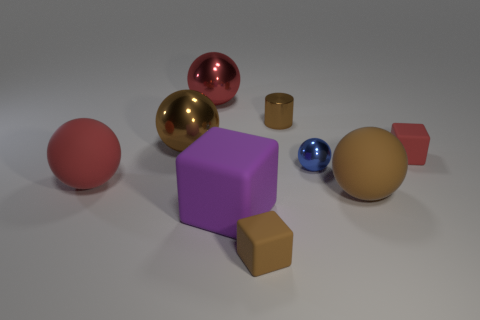Are there more brown cylinders than big yellow matte cylinders?
Offer a very short reply. Yes. What shape is the big brown thing that is on the right side of the brown block in front of the blue metal thing?
Your answer should be very brief. Sphere. Are there more blue objects behind the big red rubber object than large blue shiny objects?
Give a very brief answer. Yes. What number of rubber things are behind the red rubber sphere in front of the tiny shiny cylinder?
Give a very brief answer. 1. Is the material of the small object that is left of the tiny brown metallic thing the same as the red ball in front of the small metal cylinder?
Offer a very short reply. Yes. What number of tiny things have the same shape as the large purple matte thing?
Offer a very short reply. 2. Does the brown cube have the same material as the small brown object to the right of the brown cube?
Your answer should be very brief. No. There is a brown cylinder that is the same size as the red block; what material is it?
Offer a very short reply. Metal. Is there a brown block that has the same size as the blue shiny ball?
Make the answer very short. Yes. What shape is the blue metallic thing that is the same size as the brown matte block?
Keep it short and to the point. Sphere. 